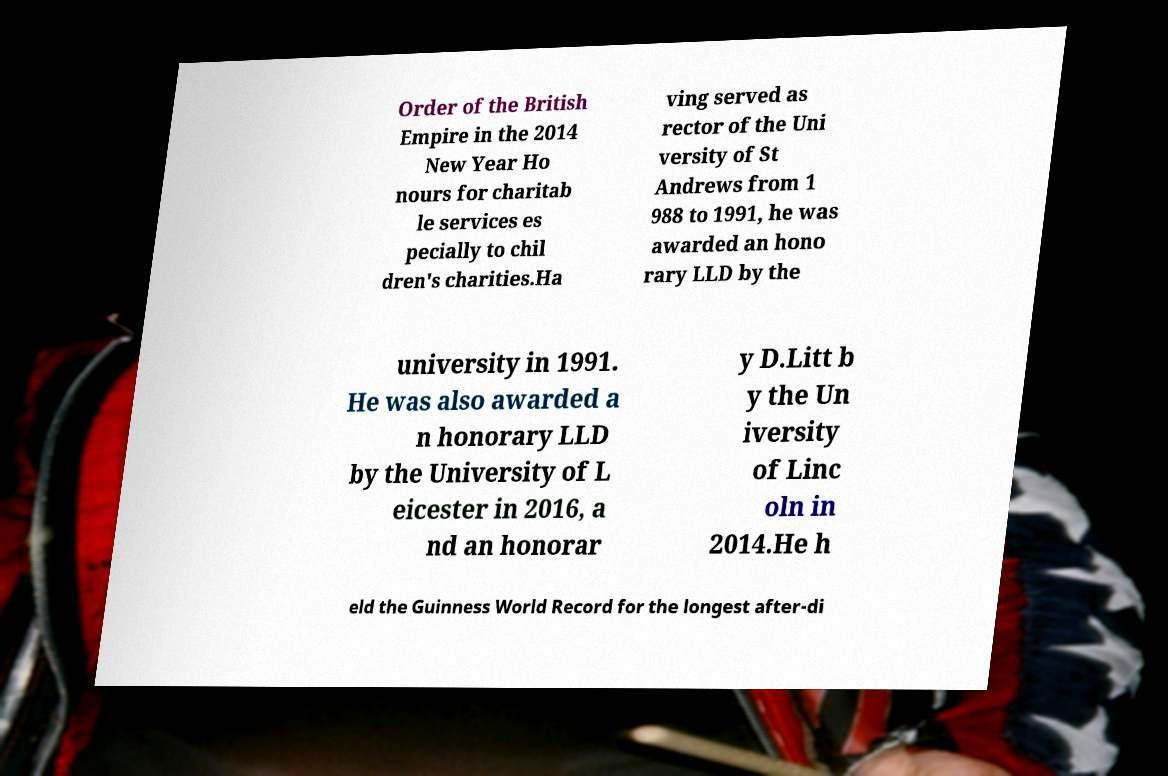I need the written content from this picture converted into text. Can you do that? Order of the British Empire in the 2014 New Year Ho nours for charitab le services es pecially to chil dren's charities.Ha ving served as rector of the Uni versity of St Andrews from 1 988 to 1991, he was awarded an hono rary LLD by the university in 1991. He was also awarded a n honorary LLD by the University of L eicester in 2016, a nd an honorar y D.Litt b y the Un iversity of Linc oln in 2014.He h eld the Guinness World Record for the longest after-di 